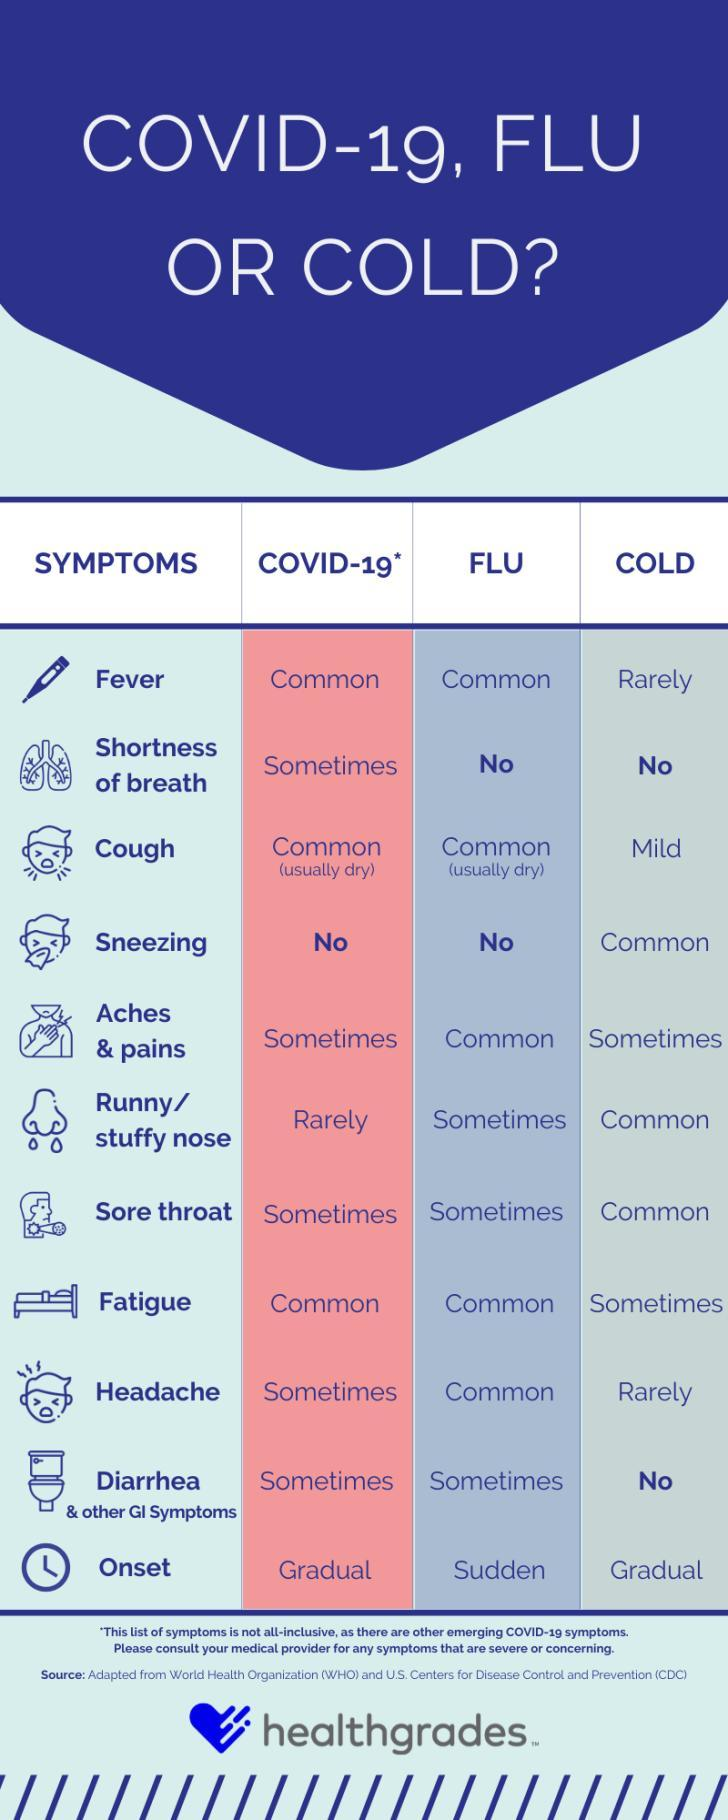Outline some significant characteristics in this image. Sneezing is the only symptom that is common only for the common cold. The symptoms of a cold that are unusual are fever and headache. COVID-19 symptoms that are rarely observed include a runny or stuffy nose. The symptom of cough is a mild indication of a cold. COVID-19 and flu and cold share some common symptoms such as cough, fever, and body aches. However, there is one symptom that is more commonly associated with COVID-19 and not flu and cold, which is shortness of breath. 